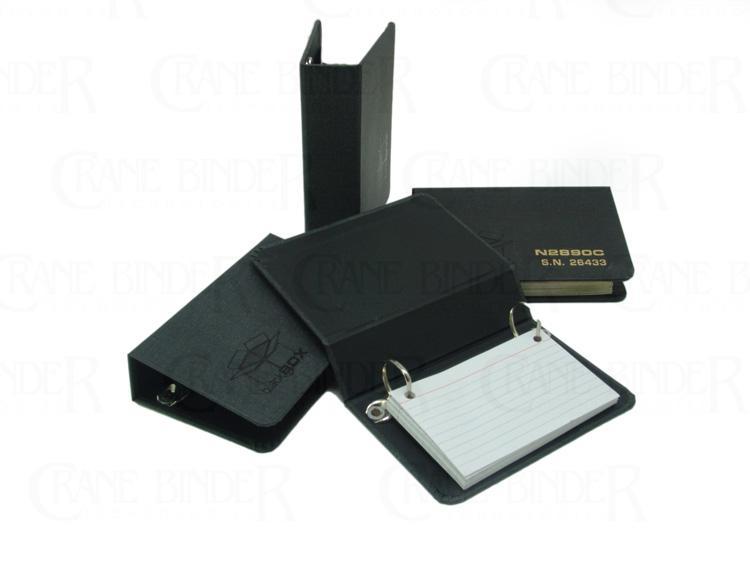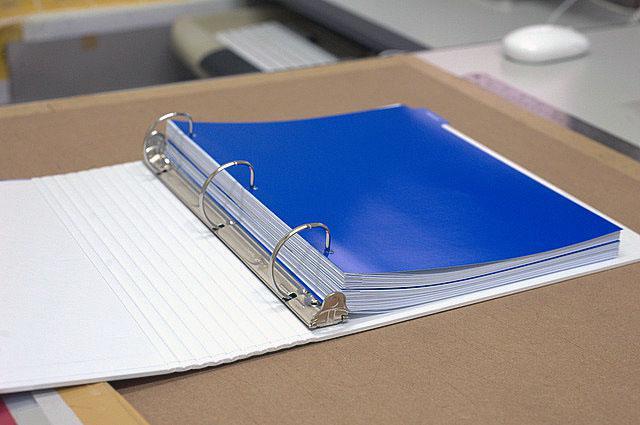The first image is the image on the left, the second image is the image on the right. Examine the images to the left and right. Is the description "An open ring binder with papers in it lies flat next to at least two upright closed binders." accurate? Answer yes or no. No. The first image is the image on the left, the second image is the image on the right. Evaluate the accuracy of this statement regarding the images: "A binder is on top of a desk.". Is it true? Answer yes or no. Yes. 